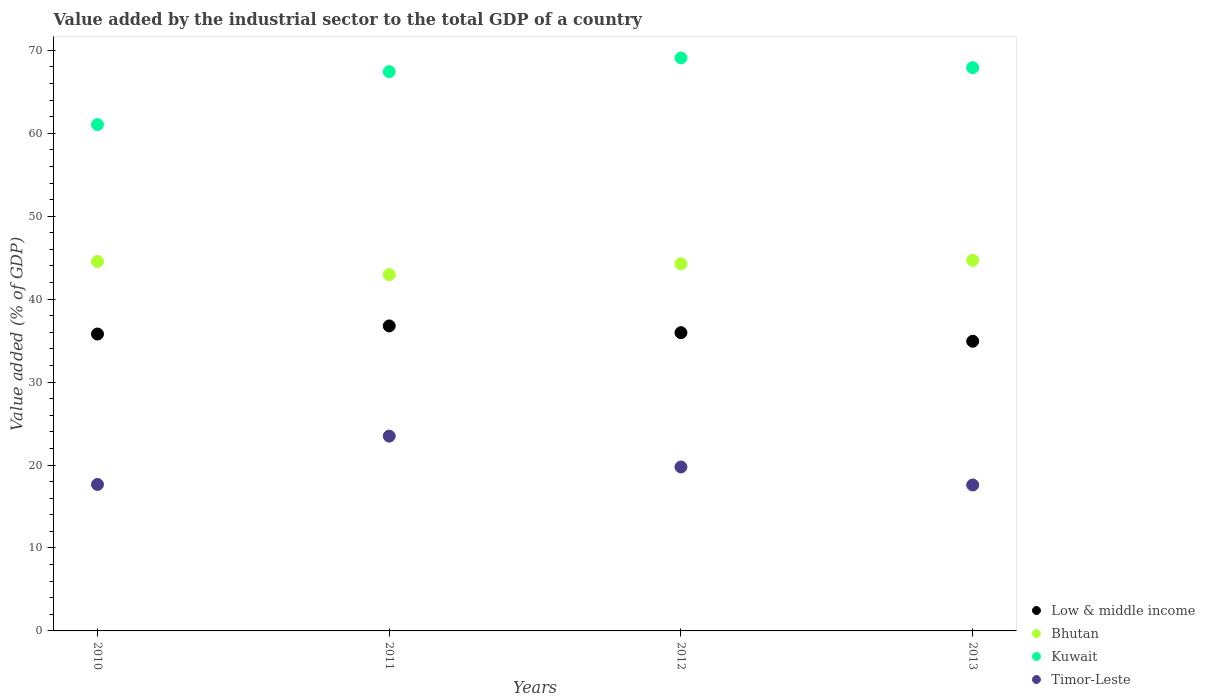What is the value added by the industrial sector to the total GDP in Timor-Leste in 2012?
Provide a succinct answer. 19.77. Across all years, what is the maximum value added by the industrial sector to the total GDP in Low & middle income?
Ensure brevity in your answer.  36.77. Across all years, what is the minimum value added by the industrial sector to the total GDP in Low & middle income?
Make the answer very short. 34.93. In which year was the value added by the industrial sector to the total GDP in Kuwait minimum?
Make the answer very short. 2010. What is the total value added by the industrial sector to the total GDP in Bhutan in the graph?
Offer a very short reply. 176.45. What is the difference between the value added by the industrial sector to the total GDP in Low & middle income in 2011 and that in 2012?
Give a very brief answer. 0.82. What is the difference between the value added by the industrial sector to the total GDP in Kuwait in 2011 and the value added by the industrial sector to the total GDP in Bhutan in 2012?
Your answer should be compact. 23.17. What is the average value added by the industrial sector to the total GDP in Low & middle income per year?
Give a very brief answer. 35.86. In the year 2013, what is the difference between the value added by the industrial sector to the total GDP in Low & middle income and value added by the industrial sector to the total GDP in Bhutan?
Provide a succinct answer. -9.76. In how many years, is the value added by the industrial sector to the total GDP in Low & middle income greater than 22 %?
Ensure brevity in your answer.  4. What is the ratio of the value added by the industrial sector to the total GDP in Timor-Leste in 2011 to that in 2013?
Make the answer very short. 1.33. Is the value added by the industrial sector to the total GDP in Bhutan in 2011 less than that in 2012?
Offer a terse response. Yes. What is the difference between the highest and the second highest value added by the industrial sector to the total GDP in Bhutan?
Provide a succinct answer. 0.14. What is the difference between the highest and the lowest value added by the industrial sector to the total GDP in Bhutan?
Make the answer very short. 1.71. In how many years, is the value added by the industrial sector to the total GDP in Low & middle income greater than the average value added by the industrial sector to the total GDP in Low & middle income taken over all years?
Your response must be concise. 2. Does the value added by the industrial sector to the total GDP in Low & middle income monotonically increase over the years?
Offer a terse response. No. Is the value added by the industrial sector to the total GDP in Low & middle income strictly greater than the value added by the industrial sector to the total GDP in Bhutan over the years?
Keep it short and to the point. No. Does the graph contain any zero values?
Offer a very short reply. No. Where does the legend appear in the graph?
Keep it short and to the point. Bottom right. How many legend labels are there?
Provide a succinct answer. 4. How are the legend labels stacked?
Your answer should be very brief. Vertical. What is the title of the graph?
Your answer should be compact. Value added by the industrial sector to the total GDP of a country. Does "Heavily indebted poor countries" appear as one of the legend labels in the graph?
Make the answer very short. No. What is the label or title of the Y-axis?
Make the answer very short. Value added (% of GDP). What is the Value added (% of GDP) of Low & middle income in 2010?
Keep it short and to the point. 35.79. What is the Value added (% of GDP) of Bhutan in 2010?
Your answer should be very brief. 44.55. What is the Value added (% of GDP) of Kuwait in 2010?
Provide a succinct answer. 61.05. What is the Value added (% of GDP) in Timor-Leste in 2010?
Keep it short and to the point. 17.66. What is the Value added (% of GDP) in Low & middle income in 2011?
Your response must be concise. 36.77. What is the Value added (% of GDP) of Bhutan in 2011?
Provide a succinct answer. 42.97. What is the Value added (% of GDP) of Kuwait in 2011?
Provide a succinct answer. 67.43. What is the Value added (% of GDP) in Timor-Leste in 2011?
Offer a terse response. 23.49. What is the Value added (% of GDP) in Low & middle income in 2012?
Your response must be concise. 35.96. What is the Value added (% of GDP) in Bhutan in 2012?
Make the answer very short. 44.26. What is the Value added (% of GDP) in Kuwait in 2012?
Your answer should be compact. 69.08. What is the Value added (% of GDP) in Timor-Leste in 2012?
Offer a terse response. 19.77. What is the Value added (% of GDP) in Low & middle income in 2013?
Keep it short and to the point. 34.93. What is the Value added (% of GDP) in Bhutan in 2013?
Offer a very short reply. 44.68. What is the Value added (% of GDP) of Kuwait in 2013?
Your answer should be compact. 67.91. What is the Value added (% of GDP) in Timor-Leste in 2013?
Offer a very short reply. 17.6. Across all years, what is the maximum Value added (% of GDP) in Low & middle income?
Your response must be concise. 36.77. Across all years, what is the maximum Value added (% of GDP) in Bhutan?
Make the answer very short. 44.68. Across all years, what is the maximum Value added (% of GDP) of Kuwait?
Offer a very short reply. 69.08. Across all years, what is the maximum Value added (% of GDP) in Timor-Leste?
Provide a short and direct response. 23.49. Across all years, what is the minimum Value added (% of GDP) of Low & middle income?
Your answer should be very brief. 34.93. Across all years, what is the minimum Value added (% of GDP) in Bhutan?
Provide a short and direct response. 42.97. Across all years, what is the minimum Value added (% of GDP) in Kuwait?
Your response must be concise. 61.05. Across all years, what is the minimum Value added (% of GDP) of Timor-Leste?
Provide a succinct answer. 17.6. What is the total Value added (% of GDP) in Low & middle income in the graph?
Offer a very short reply. 143.45. What is the total Value added (% of GDP) of Bhutan in the graph?
Provide a short and direct response. 176.45. What is the total Value added (% of GDP) of Kuwait in the graph?
Provide a succinct answer. 265.47. What is the total Value added (% of GDP) of Timor-Leste in the graph?
Your answer should be compact. 78.51. What is the difference between the Value added (% of GDP) in Low & middle income in 2010 and that in 2011?
Give a very brief answer. -0.98. What is the difference between the Value added (% of GDP) in Bhutan in 2010 and that in 2011?
Your answer should be very brief. 1.58. What is the difference between the Value added (% of GDP) of Kuwait in 2010 and that in 2011?
Give a very brief answer. -6.38. What is the difference between the Value added (% of GDP) of Timor-Leste in 2010 and that in 2011?
Your answer should be compact. -5.83. What is the difference between the Value added (% of GDP) in Low & middle income in 2010 and that in 2012?
Make the answer very short. -0.16. What is the difference between the Value added (% of GDP) of Bhutan in 2010 and that in 2012?
Ensure brevity in your answer.  0.29. What is the difference between the Value added (% of GDP) of Kuwait in 2010 and that in 2012?
Offer a terse response. -8.04. What is the difference between the Value added (% of GDP) in Timor-Leste in 2010 and that in 2012?
Your answer should be very brief. -2.11. What is the difference between the Value added (% of GDP) of Low & middle income in 2010 and that in 2013?
Offer a terse response. 0.87. What is the difference between the Value added (% of GDP) in Bhutan in 2010 and that in 2013?
Offer a very short reply. -0.14. What is the difference between the Value added (% of GDP) in Kuwait in 2010 and that in 2013?
Provide a succinct answer. -6.87. What is the difference between the Value added (% of GDP) in Timor-Leste in 2010 and that in 2013?
Keep it short and to the point. 0.06. What is the difference between the Value added (% of GDP) in Low & middle income in 2011 and that in 2012?
Offer a very short reply. 0.81. What is the difference between the Value added (% of GDP) in Bhutan in 2011 and that in 2012?
Your answer should be very brief. -1.29. What is the difference between the Value added (% of GDP) of Kuwait in 2011 and that in 2012?
Your response must be concise. -1.65. What is the difference between the Value added (% of GDP) in Timor-Leste in 2011 and that in 2012?
Your answer should be very brief. 3.72. What is the difference between the Value added (% of GDP) of Low & middle income in 2011 and that in 2013?
Your response must be concise. 1.85. What is the difference between the Value added (% of GDP) in Bhutan in 2011 and that in 2013?
Your answer should be very brief. -1.71. What is the difference between the Value added (% of GDP) in Kuwait in 2011 and that in 2013?
Make the answer very short. -0.48. What is the difference between the Value added (% of GDP) in Timor-Leste in 2011 and that in 2013?
Ensure brevity in your answer.  5.89. What is the difference between the Value added (% of GDP) in Low & middle income in 2012 and that in 2013?
Give a very brief answer. 1.03. What is the difference between the Value added (% of GDP) of Bhutan in 2012 and that in 2013?
Provide a short and direct response. -0.42. What is the difference between the Value added (% of GDP) in Kuwait in 2012 and that in 2013?
Provide a short and direct response. 1.17. What is the difference between the Value added (% of GDP) of Timor-Leste in 2012 and that in 2013?
Ensure brevity in your answer.  2.17. What is the difference between the Value added (% of GDP) in Low & middle income in 2010 and the Value added (% of GDP) in Bhutan in 2011?
Your answer should be very brief. -7.17. What is the difference between the Value added (% of GDP) in Low & middle income in 2010 and the Value added (% of GDP) in Kuwait in 2011?
Provide a succinct answer. -31.64. What is the difference between the Value added (% of GDP) in Low & middle income in 2010 and the Value added (% of GDP) in Timor-Leste in 2011?
Your response must be concise. 12.31. What is the difference between the Value added (% of GDP) of Bhutan in 2010 and the Value added (% of GDP) of Kuwait in 2011?
Ensure brevity in your answer.  -22.88. What is the difference between the Value added (% of GDP) of Bhutan in 2010 and the Value added (% of GDP) of Timor-Leste in 2011?
Offer a very short reply. 21.06. What is the difference between the Value added (% of GDP) in Kuwait in 2010 and the Value added (% of GDP) in Timor-Leste in 2011?
Your answer should be very brief. 37.56. What is the difference between the Value added (% of GDP) in Low & middle income in 2010 and the Value added (% of GDP) in Bhutan in 2012?
Offer a terse response. -8.46. What is the difference between the Value added (% of GDP) of Low & middle income in 2010 and the Value added (% of GDP) of Kuwait in 2012?
Offer a very short reply. -33.29. What is the difference between the Value added (% of GDP) of Low & middle income in 2010 and the Value added (% of GDP) of Timor-Leste in 2012?
Provide a succinct answer. 16.03. What is the difference between the Value added (% of GDP) in Bhutan in 2010 and the Value added (% of GDP) in Kuwait in 2012?
Keep it short and to the point. -24.54. What is the difference between the Value added (% of GDP) of Bhutan in 2010 and the Value added (% of GDP) of Timor-Leste in 2012?
Offer a very short reply. 24.78. What is the difference between the Value added (% of GDP) in Kuwait in 2010 and the Value added (% of GDP) in Timor-Leste in 2012?
Give a very brief answer. 41.28. What is the difference between the Value added (% of GDP) of Low & middle income in 2010 and the Value added (% of GDP) of Bhutan in 2013?
Provide a short and direct response. -8.89. What is the difference between the Value added (% of GDP) in Low & middle income in 2010 and the Value added (% of GDP) in Kuwait in 2013?
Ensure brevity in your answer.  -32.12. What is the difference between the Value added (% of GDP) of Low & middle income in 2010 and the Value added (% of GDP) of Timor-Leste in 2013?
Give a very brief answer. 18.2. What is the difference between the Value added (% of GDP) in Bhutan in 2010 and the Value added (% of GDP) in Kuwait in 2013?
Make the answer very short. -23.37. What is the difference between the Value added (% of GDP) in Bhutan in 2010 and the Value added (% of GDP) in Timor-Leste in 2013?
Provide a short and direct response. 26.95. What is the difference between the Value added (% of GDP) in Kuwait in 2010 and the Value added (% of GDP) in Timor-Leste in 2013?
Give a very brief answer. 43.45. What is the difference between the Value added (% of GDP) in Low & middle income in 2011 and the Value added (% of GDP) in Bhutan in 2012?
Your answer should be compact. -7.49. What is the difference between the Value added (% of GDP) of Low & middle income in 2011 and the Value added (% of GDP) of Kuwait in 2012?
Ensure brevity in your answer.  -32.31. What is the difference between the Value added (% of GDP) of Low & middle income in 2011 and the Value added (% of GDP) of Timor-Leste in 2012?
Your answer should be compact. 17.01. What is the difference between the Value added (% of GDP) of Bhutan in 2011 and the Value added (% of GDP) of Kuwait in 2012?
Make the answer very short. -26.12. What is the difference between the Value added (% of GDP) in Bhutan in 2011 and the Value added (% of GDP) in Timor-Leste in 2012?
Provide a succinct answer. 23.2. What is the difference between the Value added (% of GDP) of Kuwait in 2011 and the Value added (% of GDP) of Timor-Leste in 2012?
Provide a short and direct response. 47.66. What is the difference between the Value added (% of GDP) of Low & middle income in 2011 and the Value added (% of GDP) of Bhutan in 2013?
Your answer should be very brief. -7.91. What is the difference between the Value added (% of GDP) in Low & middle income in 2011 and the Value added (% of GDP) in Kuwait in 2013?
Your answer should be very brief. -31.14. What is the difference between the Value added (% of GDP) in Low & middle income in 2011 and the Value added (% of GDP) in Timor-Leste in 2013?
Your answer should be compact. 19.17. What is the difference between the Value added (% of GDP) in Bhutan in 2011 and the Value added (% of GDP) in Kuwait in 2013?
Give a very brief answer. -24.95. What is the difference between the Value added (% of GDP) in Bhutan in 2011 and the Value added (% of GDP) in Timor-Leste in 2013?
Keep it short and to the point. 25.37. What is the difference between the Value added (% of GDP) of Kuwait in 2011 and the Value added (% of GDP) of Timor-Leste in 2013?
Your response must be concise. 49.83. What is the difference between the Value added (% of GDP) in Low & middle income in 2012 and the Value added (% of GDP) in Bhutan in 2013?
Offer a terse response. -8.72. What is the difference between the Value added (% of GDP) in Low & middle income in 2012 and the Value added (% of GDP) in Kuwait in 2013?
Provide a short and direct response. -31.96. What is the difference between the Value added (% of GDP) in Low & middle income in 2012 and the Value added (% of GDP) in Timor-Leste in 2013?
Your response must be concise. 18.36. What is the difference between the Value added (% of GDP) of Bhutan in 2012 and the Value added (% of GDP) of Kuwait in 2013?
Your answer should be compact. -23.66. What is the difference between the Value added (% of GDP) of Bhutan in 2012 and the Value added (% of GDP) of Timor-Leste in 2013?
Ensure brevity in your answer.  26.66. What is the difference between the Value added (% of GDP) of Kuwait in 2012 and the Value added (% of GDP) of Timor-Leste in 2013?
Keep it short and to the point. 51.49. What is the average Value added (% of GDP) in Low & middle income per year?
Provide a succinct answer. 35.86. What is the average Value added (% of GDP) in Bhutan per year?
Your answer should be very brief. 44.11. What is the average Value added (% of GDP) in Kuwait per year?
Your response must be concise. 66.37. What is the average Value added (% of GDP) of Timor-Leste per year?
Your response must be concise. 19.63. In the year 2010, what is the difference between the Value added (% of GDP) of Low & middle income and Value added (% of GDP) of Bhutan?
Your answer should be compact. -8.75. In the year 2010, what is the difference between the Value added (% of GDP) of Low & middle income and Value added (% of GDP) of Kuwait?
Your answer should be compact. -25.25. In the year 2010, what is the difference between the Value added (% of GDP) in Low & middle income and Value added (% of GDP) in Timor-Leste?
Give a very brief answer. 18.13. In the year 2010, what is the difference between the Value added (% of GDP) in Bhutan and Value added (% of GDP) in Kuwait?
Provide a short and direct response. -16.5. In the year 2010, what is the difference between the Value added (% of GDP) in Bhutan and Value added (% of GDP) in Timor-Leste?
Your response must be concise. 26.89. In the year 2010, what is the difference between the Value added (% of GDP) of Kuwait and Value added (% of GDP) of Timor-Leste?
Provide a succinct answer. 43.39. In the year 2011, what is the difference between the Value added (% of GDP) in Low & middle income and Value added (% of GDP) in Bhutan?
Provide a succinct answer. -6.19. In the year 2011, what is the difference between the Value added (% of GDP) of Low & middle income and Value added (% of GDP) of Kuwait?
Your response must be concise. -30.66. In the year 2011, what is the difference between the Value added (% of GDP) in Low & middle income and Value added (% of GDP) in Timor-Leste?
Your response must be concise. 13.29. In the year 2011, what is the difference between the Value added (% of GDP) of Bhutan and Value added (% of GDP) of Kuwait?
Your answer should be very brief. -24.46. In the year 2011, what is the difference between the Value added (% of GDP) in Bhutan and Value added (% of GDP) in Timor-Leste?
Provide a short and direct response. 19.48. In the year 2011, what is the difference between the Value added (% of GDP) in Kuwait and Value added (% of GDP) in Timor-Leste?
Offer a terse response. 43.94. In the year 2012, what is the difference between the Value added (% of GDP) in Low & middle income and Value added (% of GDP) in Bhutan?
Your answer should be compact. -8.3. In the year 2012, what is the difference between the Value added (% of GDP) in Low & middle income and Value added (% of GDP) in Kuwait?
Offer a very short reply. -33.13. In the year 2012, what is the difference between the Value added (% of GDP) in Low & middle income and Value added (% of GDP) in Timor-Leste?
Ensure brevity in your answer.  16.19. In the year 2012, what is the difference between the Value added (% of GDP) in Bhutan and Value added (% of GDP) in Kuwait?
Your response must be concise. -24.83. In the year 2012, what is the difference between the Value added (% of GDP) of Bhutan and Value added (% of GDP) of Timor-Leste?
Offer a very short reply. 24.49. In the year 2012, what is the difference between the Value added (% of GDP) of Kuwait and Value added (% of GDP) of Timor-Leste?
Keep it short and to the point. 49.32. In the year 2013, what is the difference between the Value added (% of GDP) of Low & middle income and Value added (% of GDP) of Bhutan?
Give a very brief answer. -9.76. In the year 2013, what is the difference between the Value added (% of GDP) in Low & middle income and Value added (% of GDP) in Kuwait?
Provide a succinct answer. -32.99. In the year 2013, what is the difference between the Value added (% of GDP) of Low & middle income and Value added (% of GDP) of Timor-Leste?
Make the answer very short. 17.33. In the year 2013, what is the difference between the Value added (% of GDP) of Bhutan and Value added (% of GDP) of Kuwait?
Make the answer very short. -23.23. In the year 2013, what is the difference between the Value added (% of GDP) of Bhutan and Value added (% of GDP) of Timor-Leste?
Ensure brevity in your answer.  27.08. In the year 2013, what is the difference between the Value added (% of GDP) of Kuwait and Value added (% of GDP) of Timor-Leste?
Make the answer very short. 50.32. What is the ratio of the Value added (% of GDP) in Low & middle income in 2010 to that in 2011?
Your answer should be very brief. 0.97. What is the ratio of the Value added (% of GDP) in Bhutan in 2010 to that in 2011?
Make the answer very short. 1.04. What is the ratio of the Value added (% of GDP) in Kuwait in 2010 to that in 2011?
Your answer should be very brief. 0.91. What is the ratio of the Value added (% of GDP) of Timor-Leste in 2010 to that in 2011?
Give a very brief answer. 0.75. What is the ratio of the Value added (% of GDP) of Low & middle income in 2010 to that in 2012?
Give a very brief answer. 1. What is the ratio of the Value added (% of GDP) in Kuwait in 2010 to that in 2012?
Make the answer very short. 0.88. What is the ratio of the Value added (% of GDP) in Timor-Leste in 2010 to that in 2012?
Offer a terse response. 0.89. What is the ratio of the Value added (% of GDP) of Low & middle income in 2010 to that in 2013?
Provide a succinct answer. 1.02. What is the ratio of the Value added (% of GDP) in Bhutan in 2010 to that in 2013?
Your answer should be very brief. 1. What is the ratio of the Value added (% of GDP) of Kuwait in 2010 to that in 2013?
Provide a succinct answer. 0.9. What is the ratio of the Value added (% of GDP) of Timor-Leste in 2010 to that in 2013?
Ensure brevity in your answer.  1. What is the ratio of the Value added (% of GDP) of Low & middle income in 2011 to that in 2012?
Provide a succinct answer. 1.02. What is the ratio of the Value added (% of GDP) of Bhutan in 2011 to that in 2012?
Keep it short and to the point. 0.97. What is the ratio of the Value added (% of GDP) of Kuwait in 2011 to that in 2012?
Your answer should be very brief. 0.98. What is the ratio of the Value added (% of GDP) in Timor-Leste in 2011 to that in 2012?
Your response must be concise. 1.19. What is the ratio of the Value added (% of GDP) in Low & middle income in 2011 to that in 2013?
Provide a short and direct response. 1.05. What is the ratio of the Value added (% of GDP) in Bhutan in 2011 to that in 2013?
Offer a very short reply. 0.96. What is the ratio of the Value added (% of GDP) in Timor-Leste in 2011 to that in 2013?
Keep it short and to the point. 1.33. What is the ratio of the Value added (% of GDP) in Low & middle income in 2012 to that in 2013?
Give a very brief answer. 1.03. What is the ratio of the Value added (% of GDP) of Bhutan in 2012 to that in 2013?
Provide a short and direct response. 0.99. What is the ratio of the Value added (% of GDP) of Kuwait in 2012 to that in 2013?
Ensure brevity in your answer.  1.02. What is the ratio of the Value added (% of GDP) in Timor-Leste in 2012 to that in 2013?
Provide a short and direct response. 1.12. What is the difference between the highest and the second highest Value added (% of GDP) of Low & middle income?
Provide a short and direct response. 0.81. What is the difference between the highest and the second highest Value added (% of GDP) of Bhutan?
Your answer should be compact. 0.14. What is the difference between the highest and the second highest Value added (% of GDP) of Kuwait?
Make the answer very short. 1.17. What is the difference between the highest and the second highest Value added (% of GDP) in Timor-Leste?
Ensure brevity in your answer.  3.72. What is the difference between the highest and the lowest Value added (% of GDP) in Low & middle income?
Provide a succinct answer. 1.85. What is the difference between the highest and the lowest Value added (% of GDP) in Bhutan?
Your response must be concise. 1.71. What is the difference between the highest and the lowest Value added (% of GDP) of Kuwait?
Give a very brief answer. 8.04. What is the difference between the highest and the lowest Value added (% of GDP) of Timor-Leste?
Give a very brief answer. 5.89. 